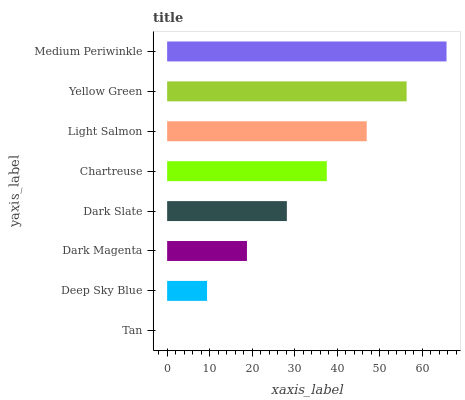Is Tan the minimum?
Answer yes or no. Yes. Is Medium Periwinkle the maximum?
Answer yes or no. Yes. Is Deep Sky Blue the minimum?
Answer yes or no. No. Is Deep Sky Blue the maximum?
Answer yes or no. No. Is Deep Sky Blue greater than Tan?
Answer yes or no. Yes. Is Tan less than Deep Sky Blue?
Answer yes or no. Yes. Is Tan greater than Deep Sky Blue?
Answer yes or no. No. Is Deep Sky Blue less than Tan?
Answer yes or no. No. Is Chartreuse the high median?
Answer yes or no. Yes. Is Dark Slate the low median?
Answer yes or no. Yes. Is Dark Magenta the high median?
Answer yes or no. No. Is Light Salmon the low median?
Answer yes or no. No. 